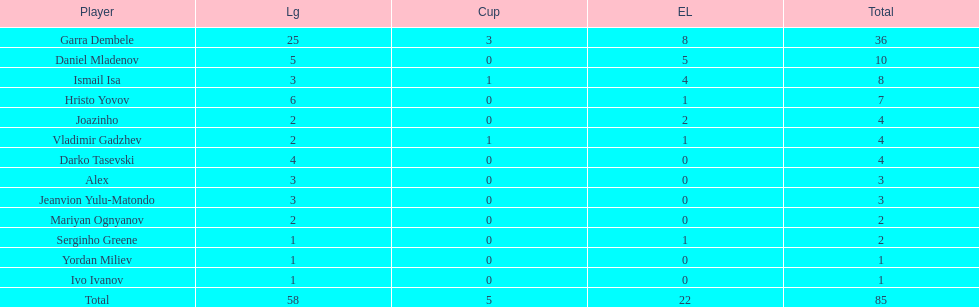What is the difference between vladimir gadzhev and yordan miliev's scores? 3. 